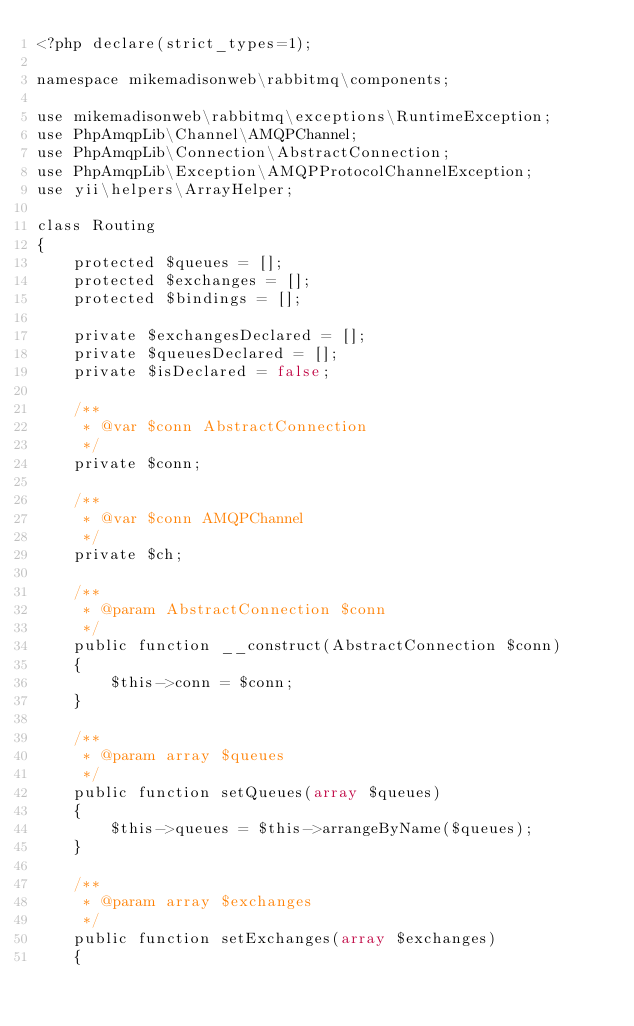<code> <loc_0><loc_0><loc_500><loc_500><_PHP_><?php declare(strict_types=1);

namespace mikemadisonweb\rabbitmq\components;

use mikemadisonweb\rabbitmq\exceptions\RuntimeException;
use PhpAmqpLib\Channel\AMQPChannel;
use PhpAmqpLib\Connection\AbstractConnection;
use PhpAmqpLib\Exception\AMQPProtocolChannelException;
use yii\helpers\ArrayHelper;

class Routing
{
    protected $queues = [];
    protected $exchanges = [];
    protected $bindings = [];

    private $exchangesDeclared = [];
    private $queuesDeclared = [];
    private $isDeclared = false;

    /**
     * @var $conn AbstractConnection
     */
    private $conn;

    /**
     * @var $conn AMQPChannel
     */
    private $ch;

    /**
     * @param AbstractConnection $conn
     */
    public function __construct(AbstractConnection $conn)
    {
        $this->conn = $conn;
    }

    /**
     * @param array $queues
     */
    public function setQueues(array $queues)
    {
        $this->queues = $this->arrangeByName($queues);
    }

    /**
     * @param array $exchanges
     */
    public function setExchanges(array $exchanges)
    {</code> 